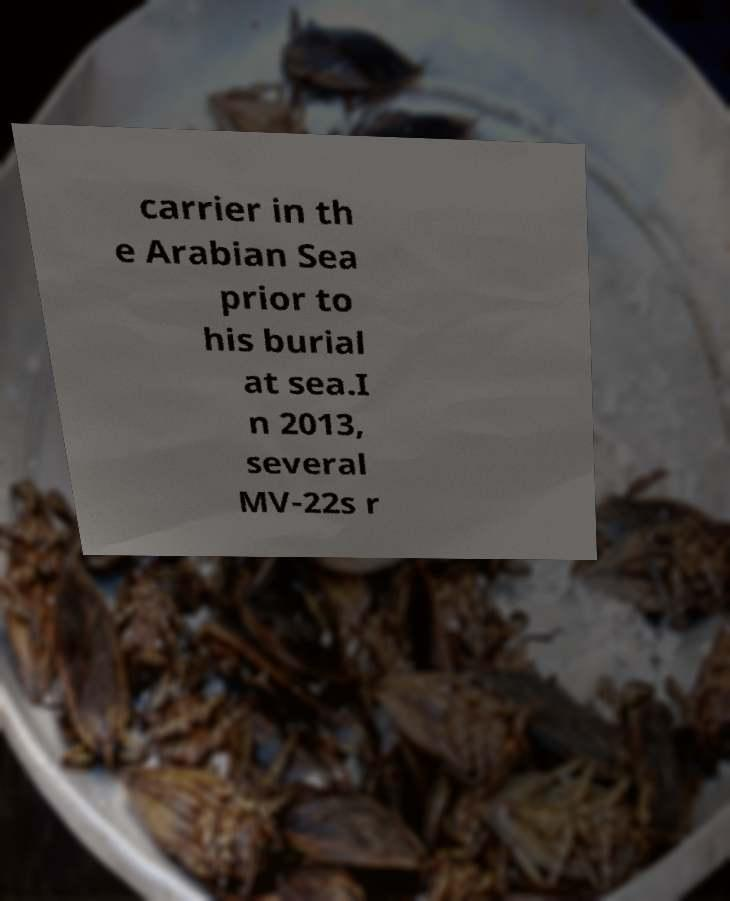Could you extract and type out the text from this image? carrier in th e Arabian Sea prior to his burial at sea.I n 2013, several MV-22s r 